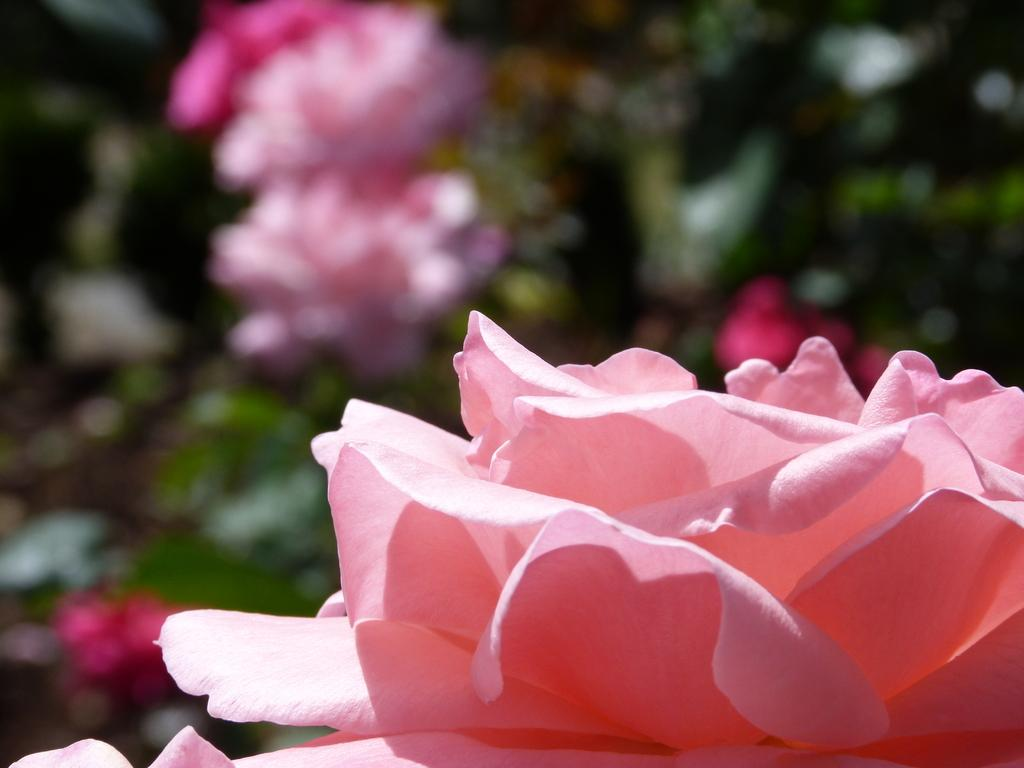What is the main subject in the foreground of the image? There is a flower in the foreground of the image. How would you describe the background of the image? The background of the image is blurred. Can you identify any other flowers in the image besides the one in the foreground? Yes, there are flowers visible in the image. What type of force is being applied to the flowers in the image? There is no indication of any force being applied to the flowers in the image. 